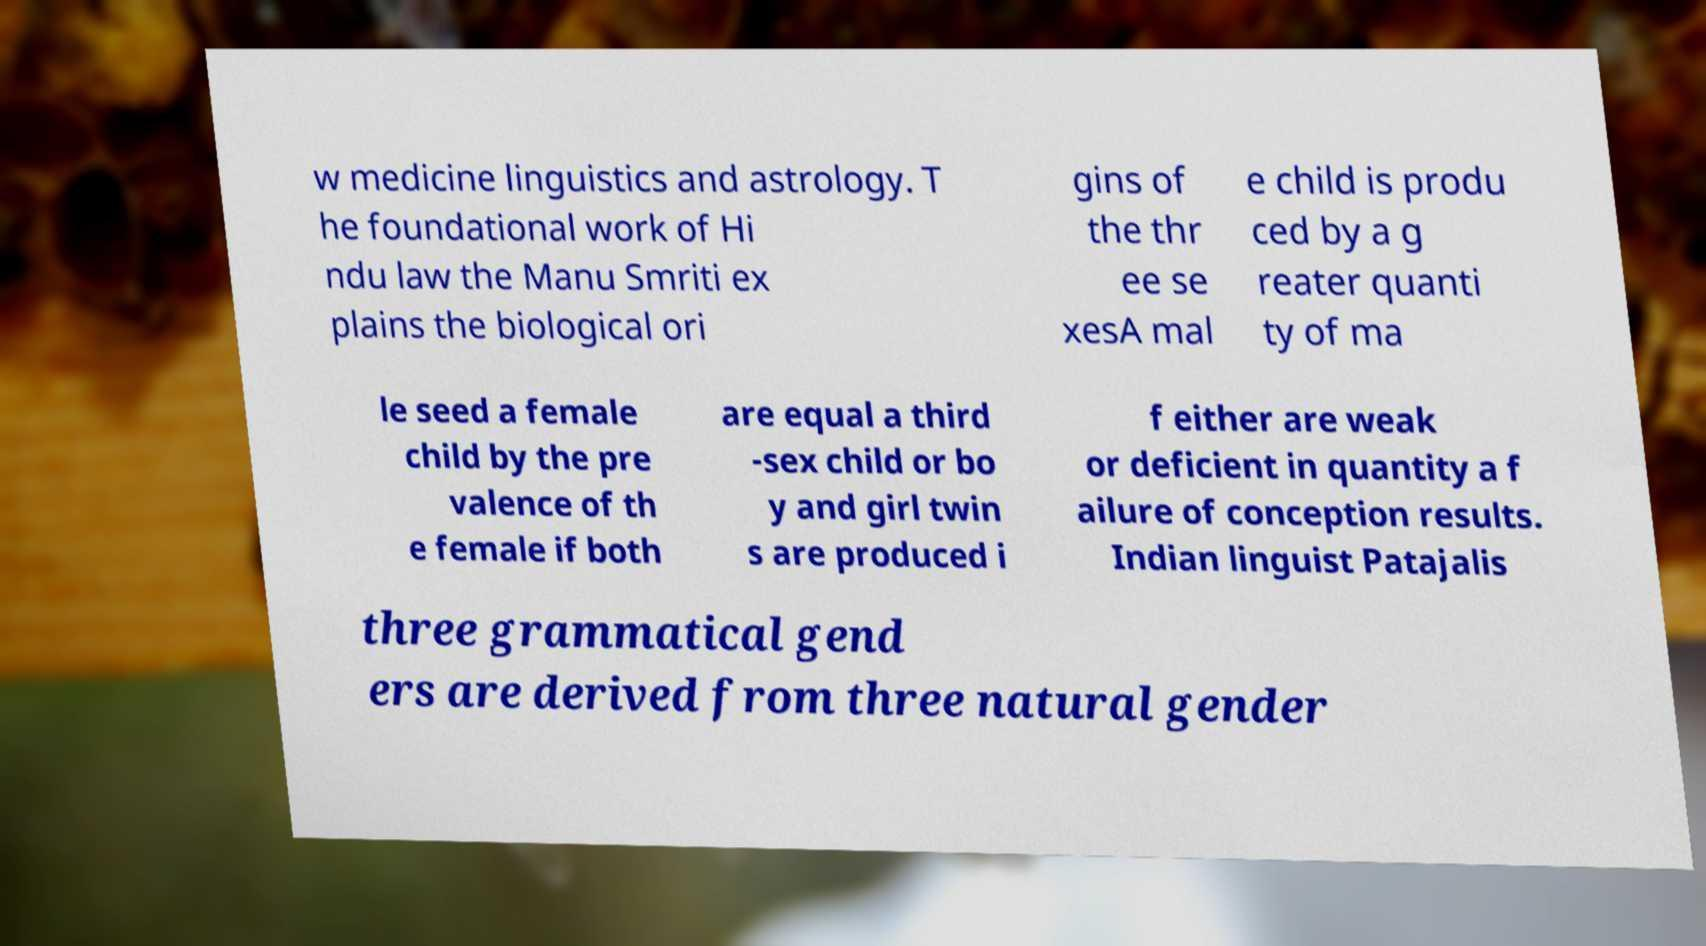There's text embedded in this image that I need extracted. Can you transcribe it verbatim? w medicine linguistics and astrology. T he foundational work of Hi ndu law the Manu Smriti ex plains the biological ori gins of the thr ee se xesA mal e child is produ ced by a g reater quanti ty of ma le seed a female child by the pre valence of th e female if both are equal a third -sex child or bo y and girl twin s are produced i f either are weak or deficient in quantity a f ailure of conception results. Indian linguist Patajalis three grammatical gend ers are derived from three natural gender 